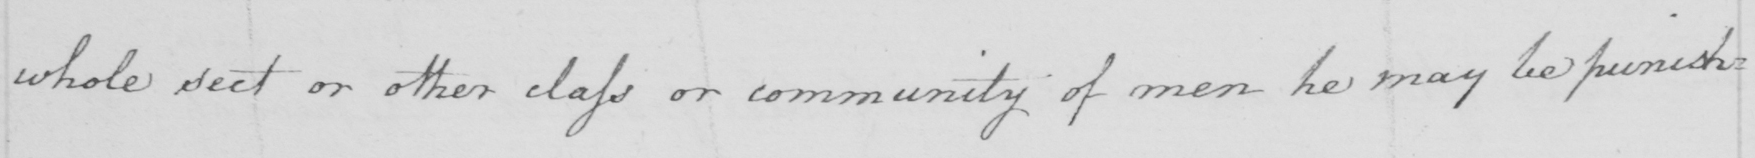Transcribe the text shown in this historical manuscript line. whole sect or other class or community of men he may be punish : 